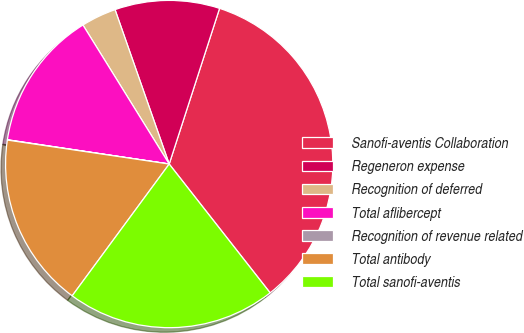<chart> <loc_0><loc_0><loc_500><loc_500><pie_chart><fcel>Sanofi-aventis Collaboration<fcel>Regeneron expense<fcel>Recognition of deferred<fcel>Total aflibercept<fcel>Recognition of revenue related<fcel>Total antibody<fcel>Total sanofi-aventis<nl><fcel>34.44%<fcel>10.35%<fcel>3.47%<fcel>13.79%<fcel>0.03%<fcel>17.24%<fcel>20.68%<nl></chart> 